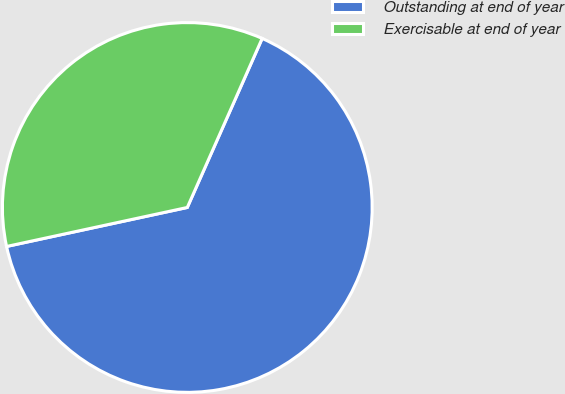Convert chart to OTSL. <chart><loc_0><loc_0><loc_500><loc_500><pie_chart><fcel>Outstanding at end of year<fcel>Exercisable at end of year<nl><fcel>64.98%<fcel>35.02%<nl></chart> 